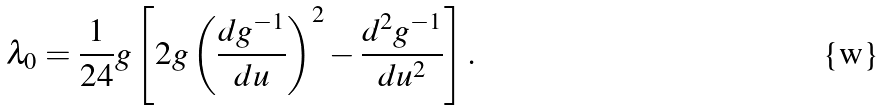<formula> <loc_0><loc_0><loc_500><loc_500>\lambda _ { 0 } = \frac { 1 } { 2 4 } g \left [ { 2 g \left ( { \frac { { d g ^ { - 1 } } } { d u } } \right ) ^ { 2 } - \frac { { d ^ { 2 } g ^ { - 1 } } } { d u ^ { 2 } } } \right ] .</formula> 